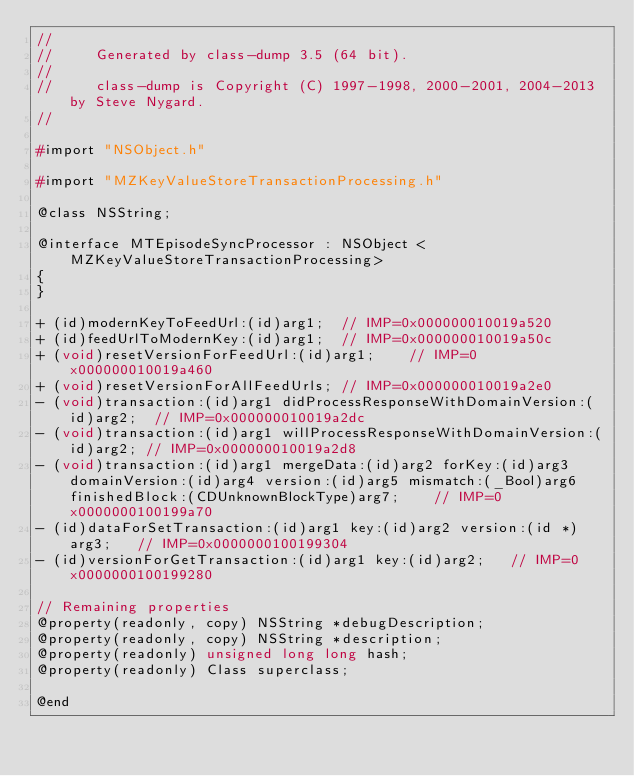Convert code to text. <code><loc_0><loc_0><loc_500><loc_500><_C_>//
//     Generated by class-dump 3.5 (64 bit).
//
//     class-dump is Copyright (C) 1997-1998, 2000-2001, 2004-2013 by Steve Nygard.
//

#import "NSObject.h"

#import "MZKeyValueStoreTransactionProcessing.h"

@class NSString;

@interface MTEpisodeSyncProcessor : NSObject <MZKeyValueStoreTransactionProcessing>
{
}

+ (id)modernKeyToFeedUrl:(id)arg1;	// IMP=0x000000010019a520
+ (id)feedUrlToModernKey:(id)arg1;	// IMP=0x000000010019a50c
+ (void)resetVersionForFeedUrl:(id)arg1;	// IMP=0x000000010019a460
+ (void)resetVersionForAllFeedUrls;	// IMP=0x000000010019a2e0
- (void)transaction:(id)arg1 didProcessResponseWithDomainVersion:(id)arg2;	// IMP=0x000000010019a2dc
- (void)transaction:(id)arg1 willProcessResponseWithDomainVersion:(id)arg2;	// IMP=0x000000010019a2d8
- (void)transaction:(id)arg1 mergeData:(id)arg2 forKey:(id)arg3 domainVersion:(id)arg4 version:(id)arg5 mismatch:(_Bool)arg6 finishedBlock:(CDUnknownBlockType)arg7;	// IMP=0x0000000100199a70
- (id)dataForSetTransaction:(id)arg1 key:(id)arg2 version:(id *)arg3;	// IMP=0x0000000100199304
- (id)versionForGetTransaction:(id)arg1 key:(id)arg2;	// IMP=0x0000000100199280

// Remaining properties
@property(readonly, copy) NSString *debugDescription;
@property(readonly, copy) NSString *description;
@property(readonly) unsigned long long hash;
@property(readonly) Class superclass;

@end

</code> 